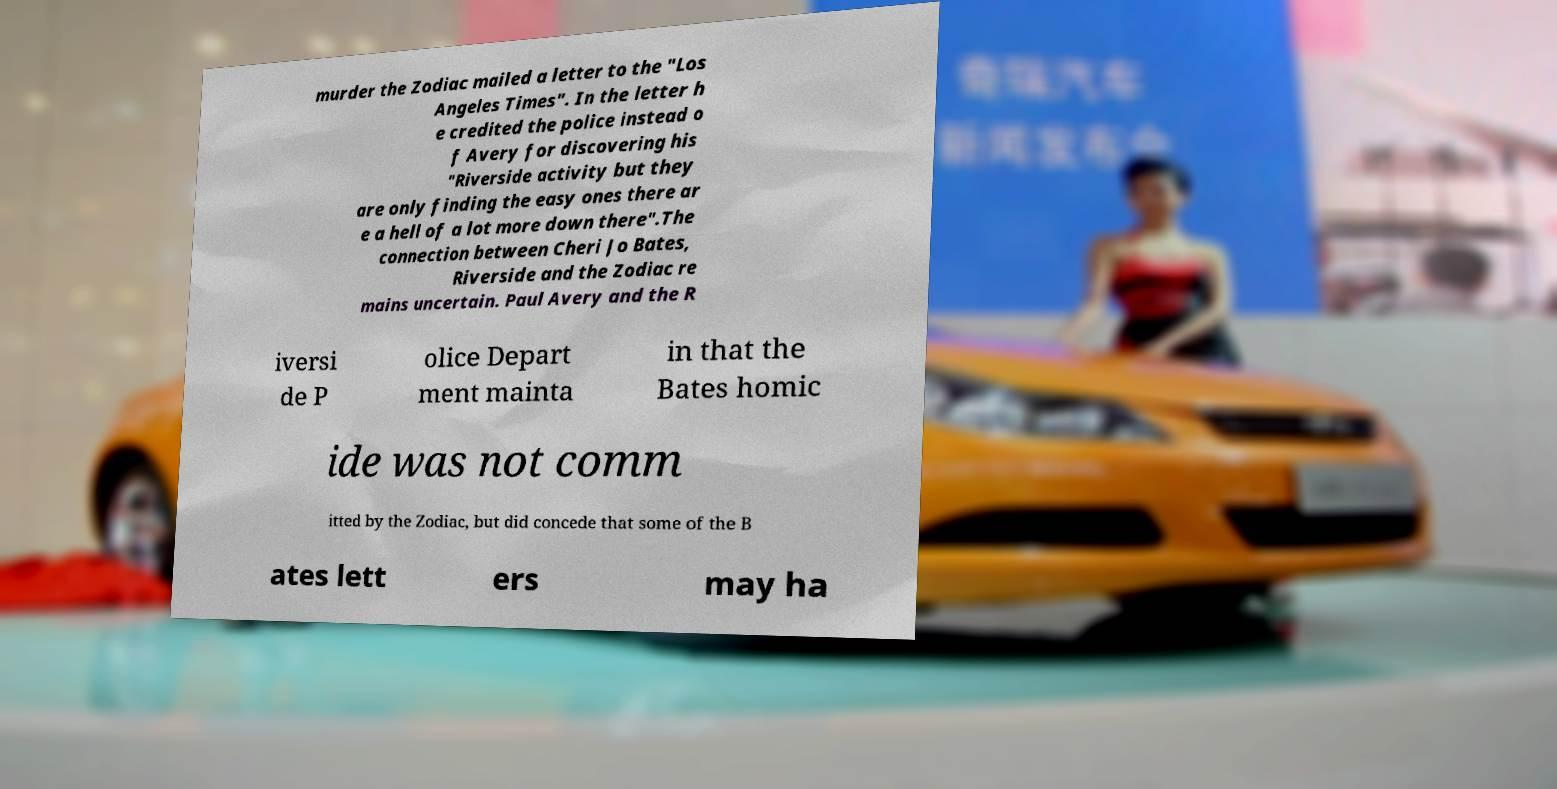There's text embedded in this image that I need extracted. Can you transcribe it verbatim? murder the Zodiac mailed a letter to the "Los Angeles Times". In the letter h e credited the police instead o f Avery for discovering his "Riverside activity but they are only finding the easy ones there ar e a hell of a lot more down there".The connection between Cheri Jo Bates, Riverside and the Zodiac re mains uncertain. Paul Avery and the R iversi de P olice Depart ment mainta in that the Bates homic ide was not comm itted by the Zodiac, but did concede that some of the B ates lett ers may ha 